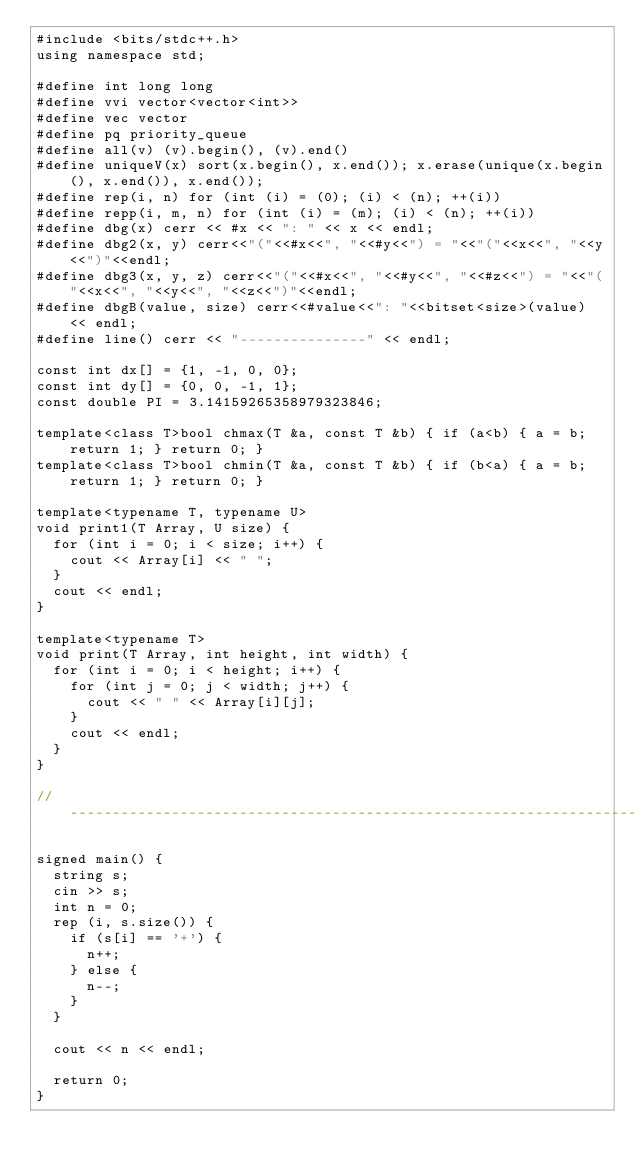Convert code to text. <code><loc_0><loc_0><loc_500><loc_500><_C++_>#include <bits/stdc++.h>
using namespace std;

#define int long long
#define vvi vector<vector<int>>
#define vec vector
#define pq priority_queue
#define all(v) (v).begin(), (v).end()
#define uniqueV(x) sort(x.begin(), x.end()); x.erase(unique(x.begin(), x.end()), x.end());
#define rep(i, n) for (int (i) = (0); (i) < (n); ++(i))
#define repp(i, m, n) for (int (i) = (m); (i) < (n); ++(i))
#define dbg(x) cerr << #x << ": " << x << endl;
#define dbg2(x, y) cerr<<"("<<#x<<", "<<#y<<") = "<<"("<<x<<", "<<y<<")"<<endl;
#define dbg3(x, y, z) cerr<<"("<<#x<<", "<<#y<<", "<<#z<<") = "<<"("<<x<<", "<<y<<", "<<z<<")"<<endl;
#define dbgB(value, size) cerr<<#value<<": "<<bitset<size>(value) << endl;
#define line() cerr << "---------------" << endl;

const int dx[] = {1, -1, 0, 0};
const int dy[] = {0, 0, -1, 1};
const double PI = 3.14159265358979323846;

template<class T>bool chmax(T &a, const T &b) { if (a<b) { a = b; return 1; } return 0; }
template<class T>bool chmin(T &a, const T &b) { if (b<a) { a = b; return 1; } return 0; }

template<typename T, typename U>
void print1(T Array, U size) {
  for (int i = 0; i < size; i++) {
    cout << Array[i] << " ";
  }
  cout << endl;
}

template<typename T>
void print(T Array, int height, int width) {
  for (int i = 0; i < height; i++) {
    for (int j = 0; j < width; j++) {
      cout << " " << Array[i][j];
    }
    cout << endl;
  }
}

// ------------------------------------------------------------------------------------------

signed main() {
  string s;
  cin >> s;
  int n = 0;
  rep (i, s.size()) {
    if (s[i] == '+') {
      n++;
    } else {
      n--;
    }
  }

  cout << n << endl;

  return 0;
}</code> 